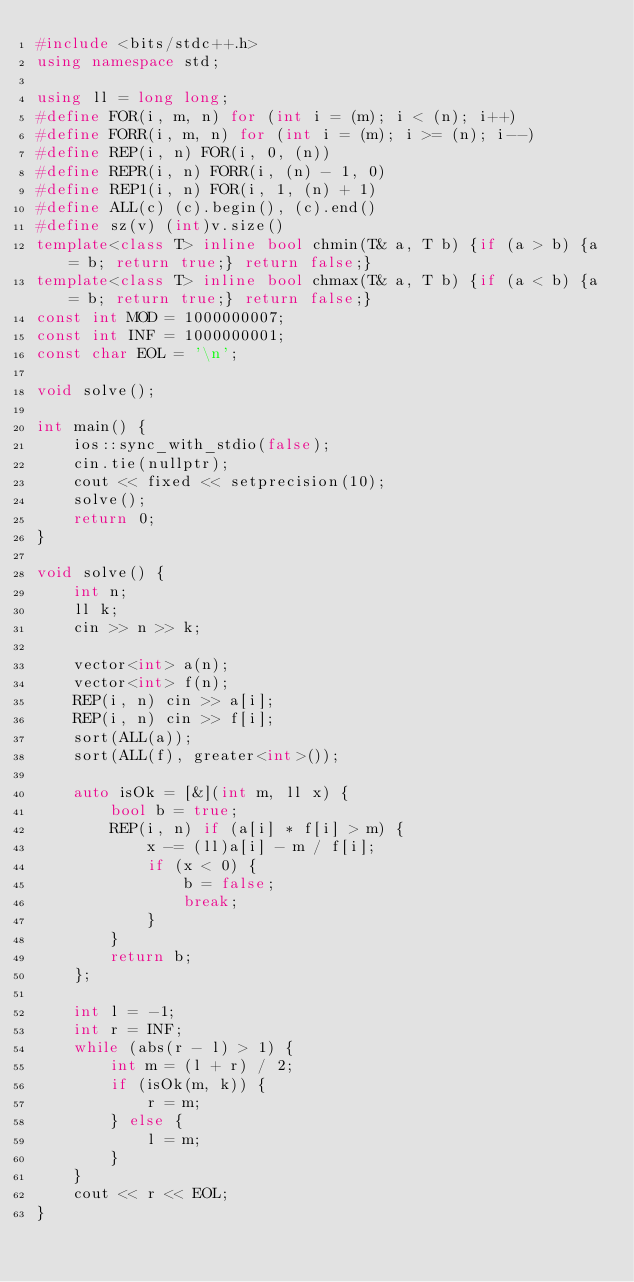<code> <loc_0><loc_0><loc_500><loc_500><_C++_>#include <bits/stdc++.h>
using namespace std;

using ll = long long;
#define FOR(i, m, n) for (int i = (m); i < (n); i++)
#define FORR(i, m, n) for (int i = (m); i >= (n); i--)
#define REP(i, n) FOR(i, 0, (n))
#define REPR(i, n) FORR(i, (n) - 1, 0)
#define REP1(i, n) FOR(i, 1, (n) + 1)
#define ALL(c) (c).begin(), (c).end()
#define sz(v) (int)v.size()
template<class T> inline bool chmin(T& a, T b) {if (a > b) {a = b; return true;} return false;}
template<class T> inline bool chmax(T& a, T b) {if (a < b) {a = b; return true;} return false;}
const int MOD = 1000000007;
const int INF = 1000000001;
const char EOL = '\n';

void solve();

int main() {
    ios::sync_with_stdio(false);
    cin.tie(nullptr);
    cout << fixed << setprecision(10);
    solve();
    return 0;
}

void solve() {
    int n;
    ll k;
    cin >> n >> k;

    vector<int> a(n);
    vector<int> f(n);
    REP(i, n) cin >> a[i];
    REP(i, n) cin >> f[i];
    sort(ALL(a));
    sort(ALL(f), greater<int>());

    auto isOk = [&](int m, ll x) {
        bool b = true;
        REP(i, n) if (a[i] * f[i] > m) {
            x -= (ll)a[i] - m / f[i];
            if (x < 0) {
                b = false;
                break;
            }
        }
        return b;
    };

    int l = -1;
    int r = INF;
    while (abs(r - l) > 1) {
        int m = (l + r) / 2;
        if (isOk(m, k)) {
            r = m;
        } else {
            l = m;
        }
    }
    cout << r << EOL;
}
</code> 